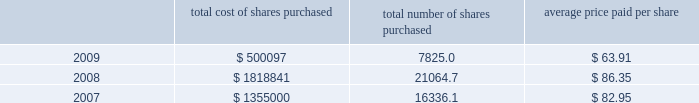Part ii , item 7 until maturity , effectively making this a us dollar denominated debt on which schlumberger will pay interest in us dollars at a rate of 4.74% ( 4.74 % ) .
The proceeds from these notes were used to repay commercial paper borrowings .
0160 on april 20 , 2006 , the schlumberger board of directors approved a share repurchase program of up to 40 million shares of common stock to be acquired in the open market before april 2010 , subject to market conditions .
This program was completed during the second quarter of 2008 .
On april 17 , 2008 , the schlumberger board of directors approved an $ 8 billion share repurchase program for shares of schlumberger common stock , to be acquired in the open market before december 31 , 2011 , of which $ 1.43 billion had been repurchased as of december 31 , 2009 .
The table summarizes the activity under these share repurchase programs during 2009 , 2008 and ( stated in thousands except per share amounts and prices ) total cost of shares purchased total number of shares purchased average price paid per share .
0160 cash flow provided by operations was $ 5.3 billion in 2009 , $ 6.9 billion in 2008 and $ 6.3 billion in 2007 .
The decline in cash flow from operations in 2009 as compared to 2008 was primarily driven by the decrease in net income experienced in 2009 and the significant pension plan contributions made during 2009 , offset by an improvement in working capital requirements .
The improvement in 2008 as compared to 2007 was driven by the net income increase experienced in 2008 offset by required investments in working capital .
The reduction in cash flows experienced by some of schlumberger 2019s customers as a result of global economic conditions could have significant adverse effects on their financial condition .
This could result in , among other things , delay in , or nonpayment of , amounts that are owed to schlumberger , which could have a material adverse effect on schlumberger 2019s results of operations and cash flows .
At times in recent quarters , schlumberger has experienced delays in payments from certain of its customers .
Schlumberger operates in approximately 80 countries .
At december 31 , 2009 , only three of those countries individually accounted for greater than 5% ( 5 % ) of schlumberger 2019s accounts receivable balance of which only one represented greater than 0160 during 2008 and 2007 , schlumberger announced that its board of directors had approved increases in the quarterly dividend of 20% ( 20 % ) and 40% ( 40 % ) , respectively .
Total dividends paid during 2009 , 2008 and 2007 were $ 1.0 billion , $ 964 million and $ 771 million , respectively .
0160 capital expenditures were $ 2.4 billion in 2009 , $ 3.7 billion in 2008 and $ 2.9 billion in 2007 .
Capital expenditures in 2008 and 2007 reflected the record activity levels experienced in those years .
The decrease in capital expenditures in 2009 as compared to 2008 is primarily due to the significant activity decline during 2009 .
Oilfield services capital expenditures are expected to approach $ 2.4 billion for the full year 2010 as compared to $ 1.9 billion in 2009 and $ 3.0 billion in 2008 .
Westerngeco capital expenditures are expected to approach $ 0.3 billion for the full year 2010 as compared to $ 0.5 billion in 2009 and $ 0.7 billion in 2008. .
As of december 31 , 2009 what was the remaining percentage outstanding of the $ 8 billion share repurchase program for shares of schlumberger common stock as approved by the board? 
Rationale: the outstanding amount is the difference in the amount authorized and the amount acquired
Computations: ((8 - 1.43) / 8)
Answer: 0.82125. 